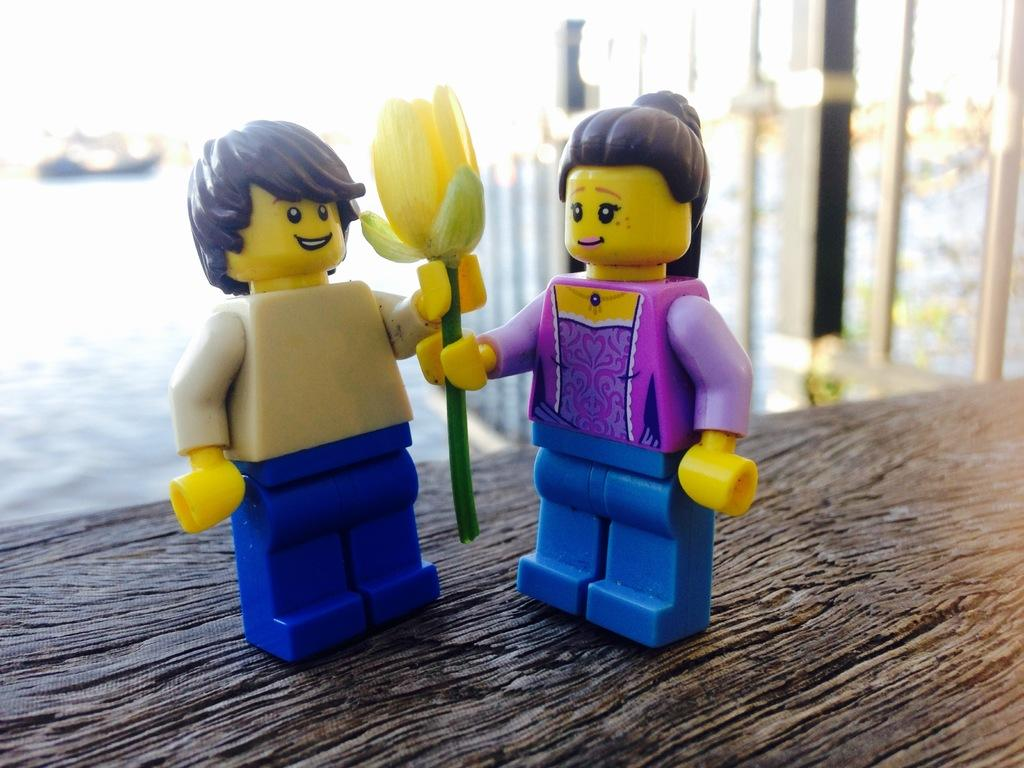How many toys are present in the image? There are two toys in the image. What are the toys doing in the image? The toys are holding a yellow flower. Where are the toys located in the image? The toys are on a table. What else can be seen in the image besides the toys? There are poles and objects in the background of the image. How is the background of the image depicted? The background of the image is blurred. What type of marble is used to create the toys in the image? There is no marble used to create the toys in the image; they are likely made of plastic or another material. 